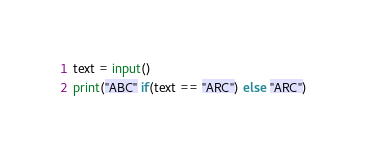Convert code to text. <code><loc_0><loc_0><loc_500><loc_500><_Python_>text = input()
print("ABC" if(text == "ARC") else "ARC")</code> 